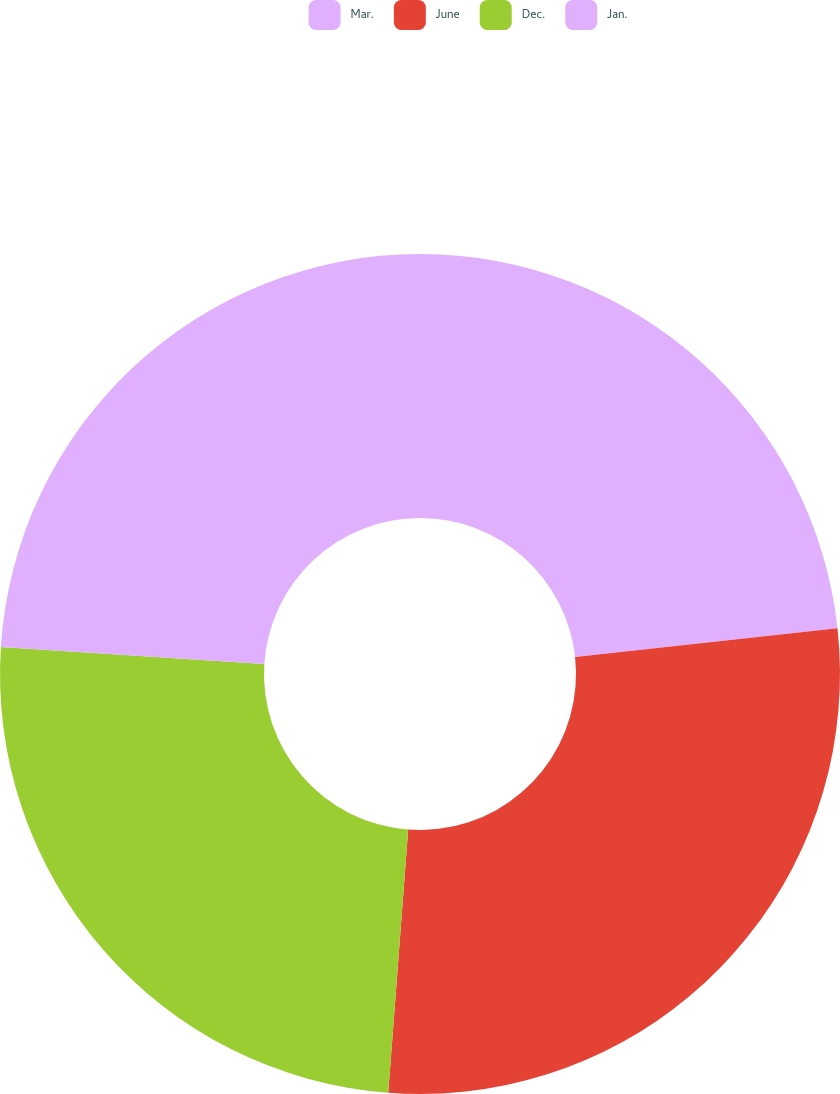<chart> <loc_0><loc_0><loc_500><loc_500><pie_chart><fcel>Mar.<fcel>June<fcel>Dec.<fcel>Jan.<nl><fcel>23.26%<fcel>27.94%<fcel>24.82%<fcel>23.97%<nl></chart> 